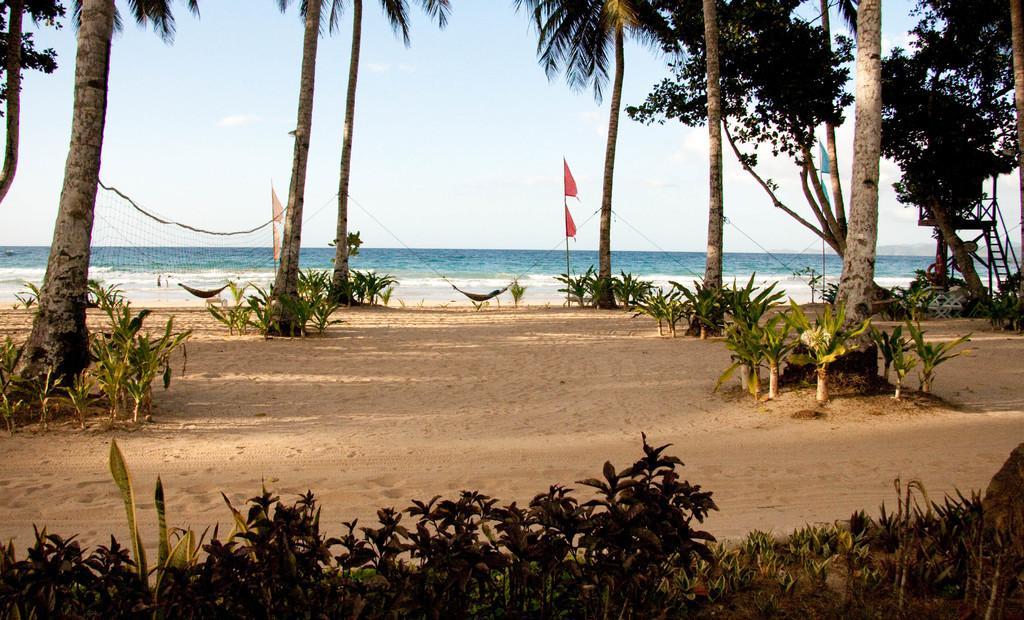How would you summarize this image in a sentence or two? In this picture I can see trees, plants and I can see couple of nets, few flags and couple of hammocks. I can see water and a blue sky in the background and looks like a wooden check post on the right side. 